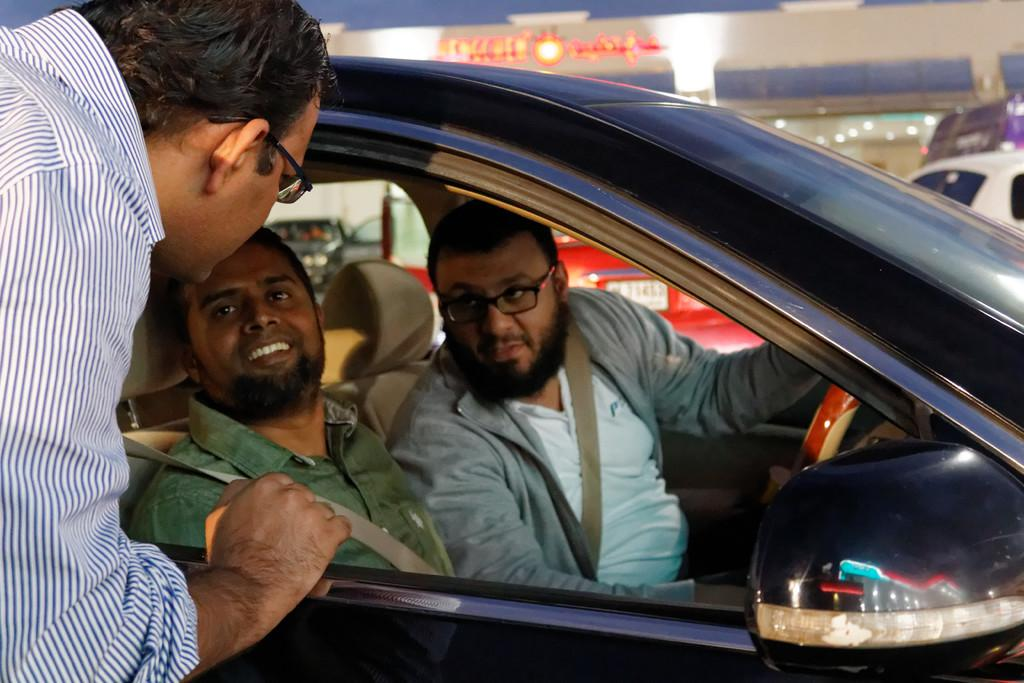What is the main subject of the image? The main subject of the image is two men sitting in a car. Are there any other people in the image? Yes, there is a man standing nearby. What might the men in the car be doing? They could be waiting, talking, or driving. What type of flight is the man in the car planning to take? There is no indication of any flight or travel plans in the image. 